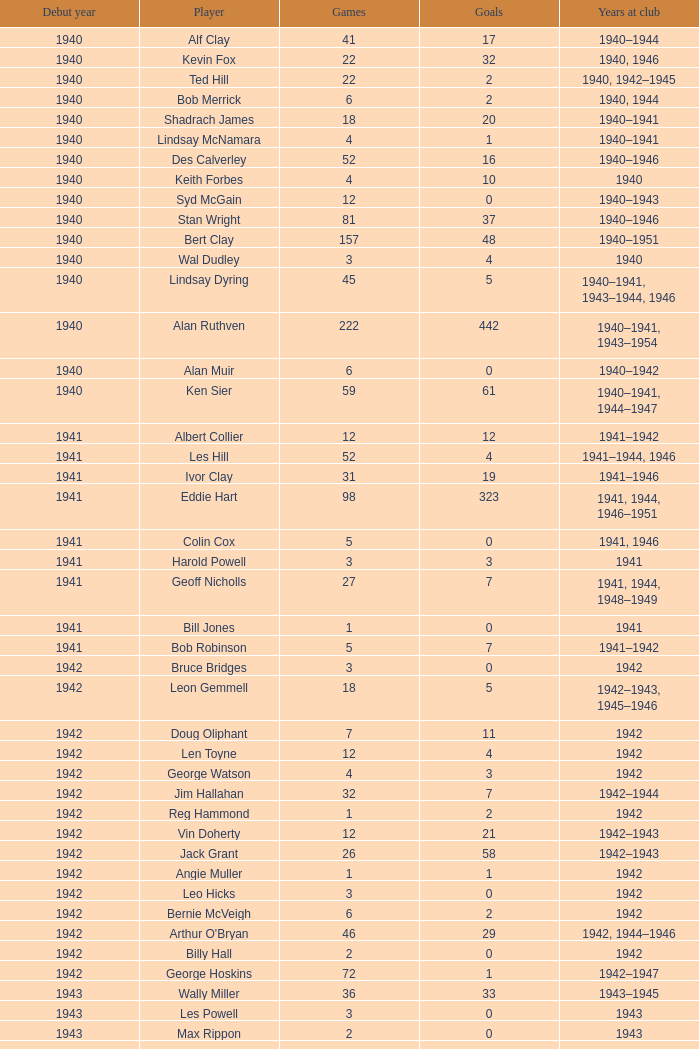Which athlete made their debut prior to 1943, participated in the team in 1942, played fewer than 12 matches, and netted under 11 goals? Bruce Bridges, George Watson, Reg Hammond, Angie Muller, Leo Hicks, Bernie McVeigh, Billy Hall. 